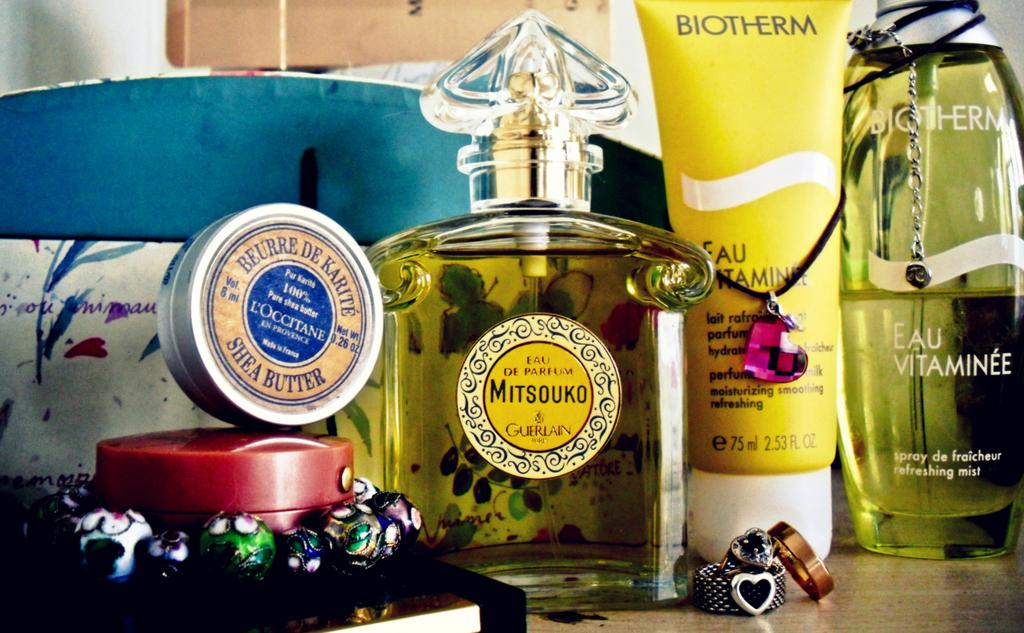<image>
Present a compact description of the photo's key features. Bottle of Mitsouko next to a bottle of Biotherm. 